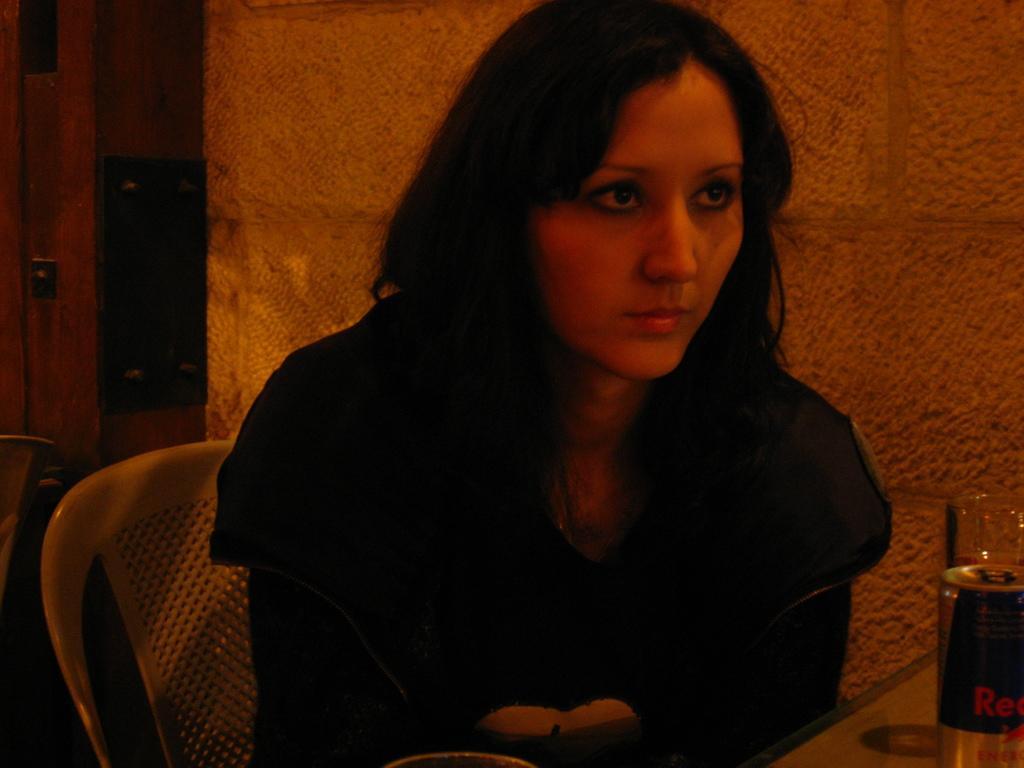In one or two sentences, can you explain what this image depicts? In this image in the center there is one woman who is sitting on a chair and on the background there is a wall. On the left side there is a door on the right side there is one coke container and one table is there, beside the coke container there is one glass. 